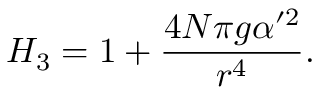Convert formula to latex. <formula><loc_0><loc_0><loc_500><loc_500>H _ { 3 } = 1 + { \frac { 4 N \pi g \alpha ^ { \prime 2 } } { r ^ { 4 } } } .</formula> 